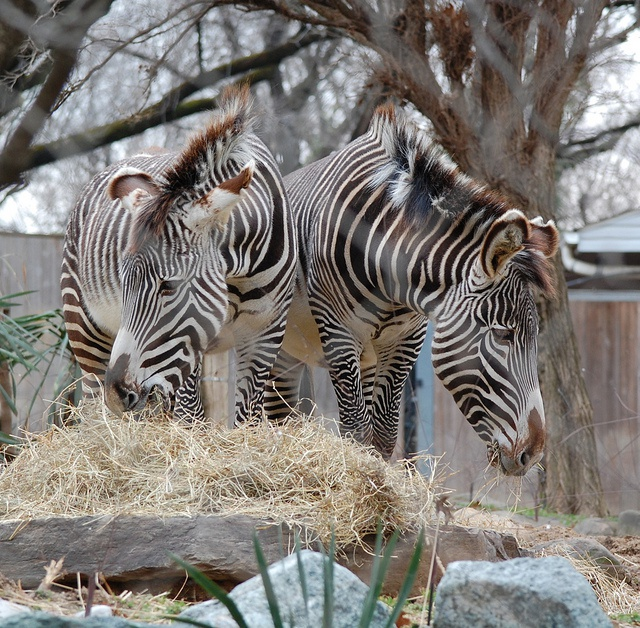Describe the objects in this image and their specific colors. I can see zebra in gray, black, and darkgray tones and zebra in gray, darkgray, black, and lightgray tones in this image. 